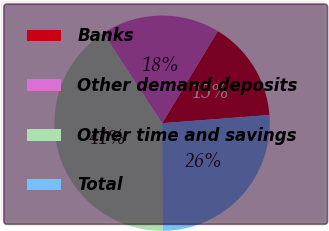Convert chart to OTSL. <chart><loc_0><loc_0><loc_500><loc_500><pie_chart><fcel>Banks<fcel>Other demand deposits<fcel>Other time and savings<fcel>Total<nl><fcel>15.12%<fcel>17.87%<fcel>40.89%<fcel>26.12%<nl></chart> 